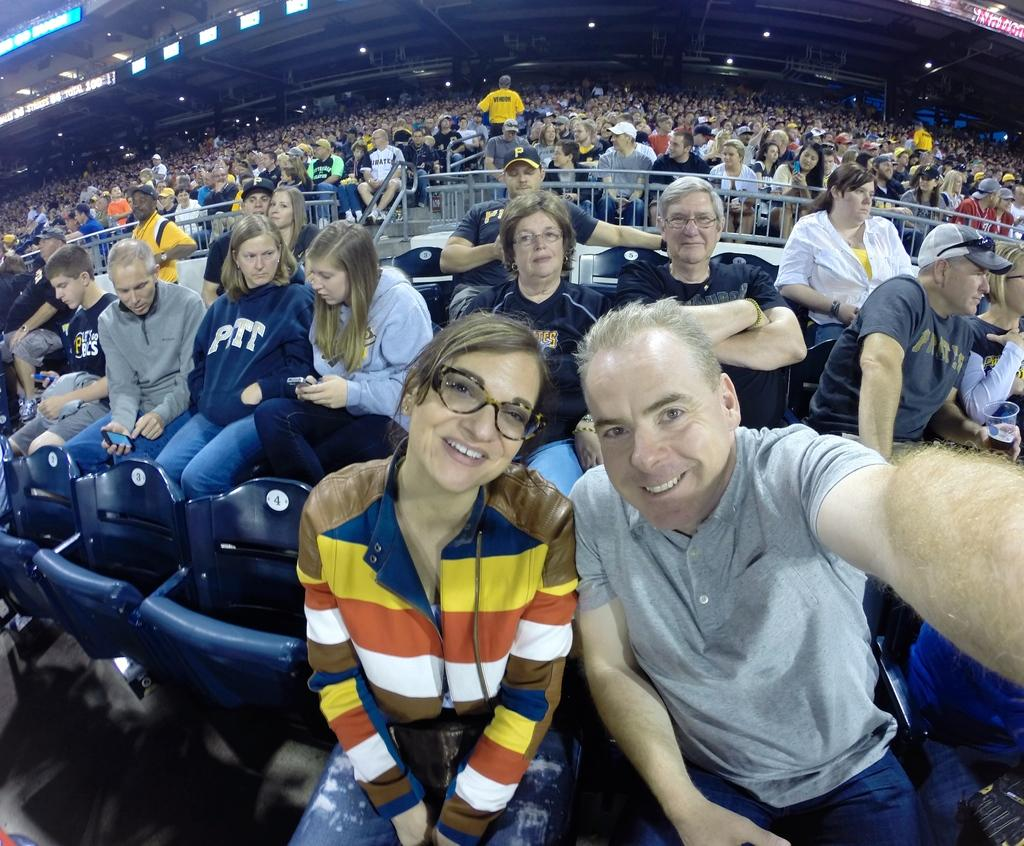Who or what can be seen in the image? There are people in the image. What type of structure is visible in the image? There is a stadium in the image. What type of seating is available in the image? There are chairs in the image. What type of illumination is present in the image? There are lights in the image. What type of safety feature is visible in the image? There are railings in the image. What type of signage is present in the image? There are boards in the image. What type of property is being offered for sale in the image? There is no property being offered for sale in the image; it features a stadium with people, chairs, lights, railings, and boards. How many cows can be seen grazing in the image? There are no cows present in the image. 